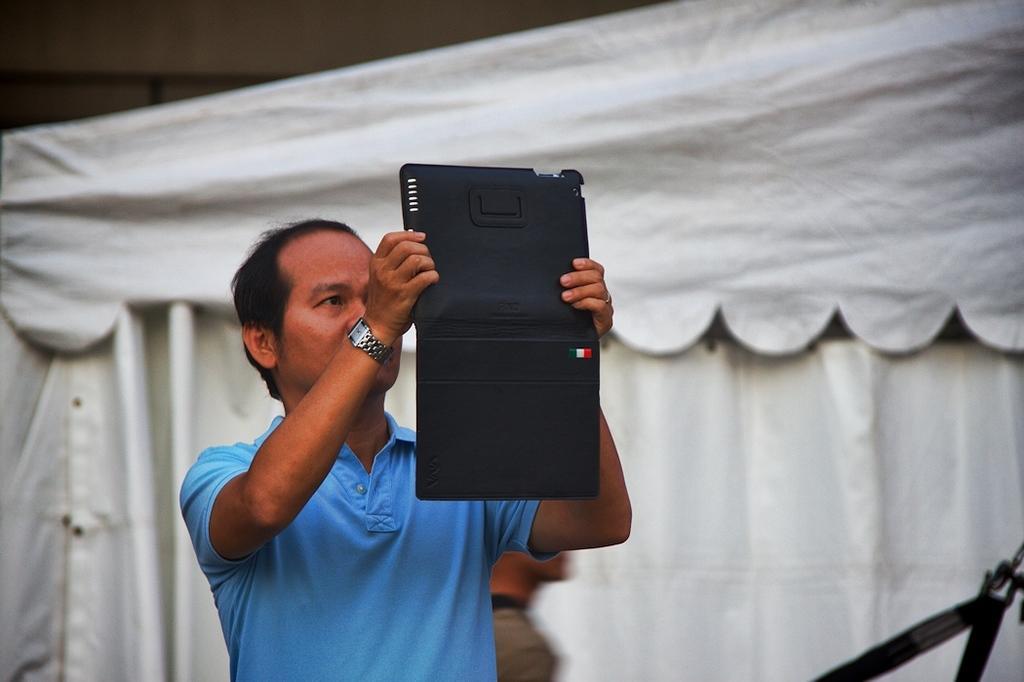Can you describe this image briefly? In the middle of the image there is a man with blue t-shirt is standing and holding the tab with black cover. To his hand there is a watch. Behind him there is a white color tint. 